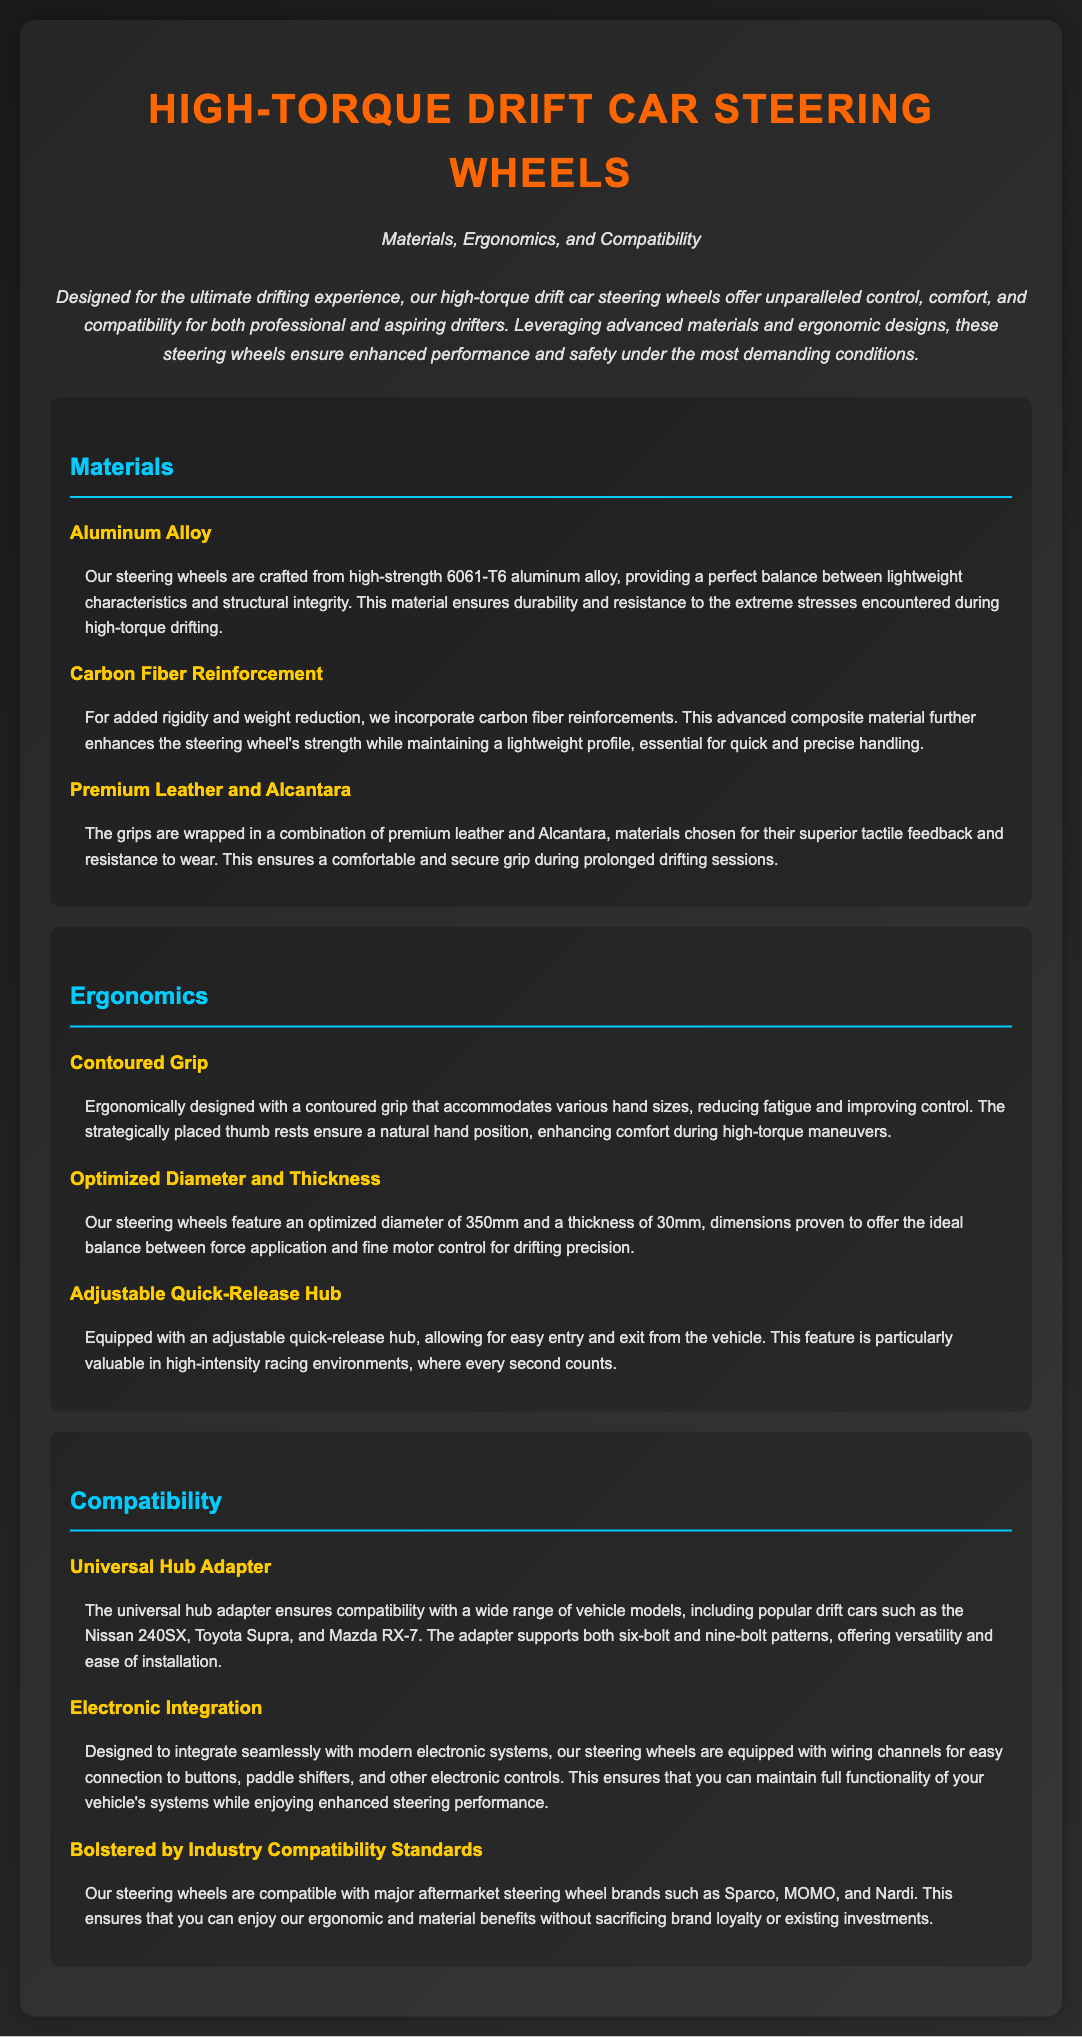What type of aluminum alloy is used? The steering wheels are crafted from high-strength 6061-T6 aluminum alloy, known for its lightweight and structural integrity.
Answer: 6061-T6 aluminum alloy What is the optimized diameter of the steering wheels? The steering wheels feature an optimized diameter of 350mm, which is proven to be ideal for drifting precision.
Answer: 350mm Which material is used for the grips? The grips are wrapped in a combination of premium leather and Alcantara, chosen for their tactile feedback and wear resistance.
Answer: Premium leather and Alcantara How thick are the steering wheels? The steering wheels have a thickness of 30mm, which balances force application and fine motor control.
Answer: 30mm What type of adapter is included for compatibility? The steering wheels come with a universal hub adapter, ensuring wide compatibility with various vehicle models.
Answer: Universal hub adapter What feature allows for easy entry and exit from the vehicle? The adjustable quick-release hub is specifically designed to allow easy entry and exit, valuable in racing environments.
Answer: Adjustable quick-release hub Which popular drift cars are mentioned as compatible? The steering wheels are compatible with popular drift cars such as the Nissan 240SX, Toyota Supra, and Mazda RX-7.
Answer: Nissan 240SX, Toyota Supra, Mazda RX-7 What is integrated into the steering wheels for electronic systems? The steering wheels are equipped with wiring channels for easy connection to buttons, paddle shifters, and electronic controls.
Answer: Wiring channels What is the optimized grip design feature? The steering wheels are designed with a contoured grip that accommodates various hand sizes, reducing fatigue and improving control.
Answer: Contoured grip 